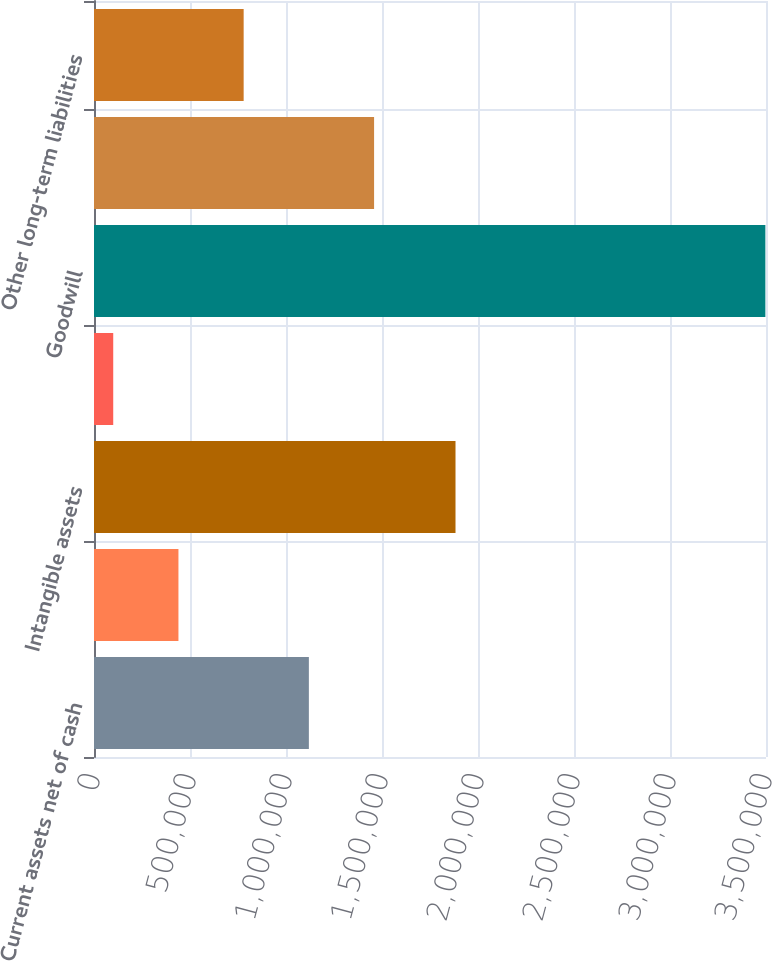Convert chart. <chart><loc_0><loc_0><loc_500><loc_500><bar_chart><fcel>Current assets net of cash<fcel>Property and equipment<fcel>Intangible assets<fcel>Other long-term assets<fcel>Goodwill<fcel>Current liabilities assumed<fcel>Other long-term liabilities<nl><fcel>1.11911e+06<fcel>439800<fcel>1.88282e+06<fcel>100143<fcel>3.49671e+06<fcel>1.45877e+06<fcel>779457<nl></chart> 